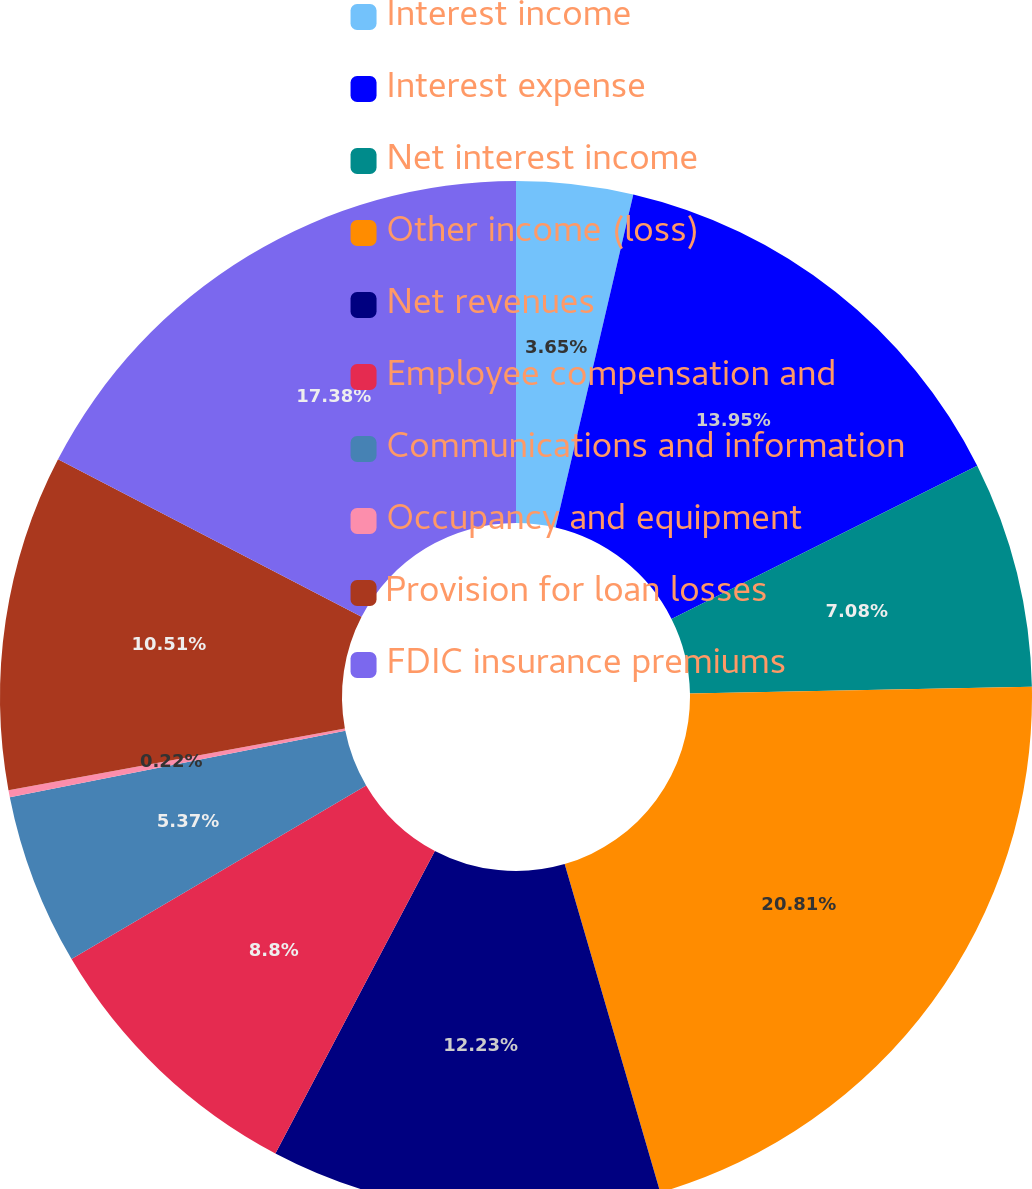Convert chart to OTSL. <chart><loc_0><loc_0><loc_500><loc_500><pie_chart><fcel>Interest income<fcel>Interest expense<fcel>Net interest income<fcel>Other income (loss)<fcel>Net revenues<fcel>Employee compensation and<fcel>Communications and information<fcel>Occupancy and equipment<fcel>Provision for loan losses<fcel>FDIC insurance premiums<nl><fcel>3.65%<fcel>13.95%<fcel>7.08%<fcel>20.81%<fcel>12.23%<fcel>8.8%<fcel>5.37%<fcel>0.22%<fcel>10.51%<fcel>17.38%<nl></chart> 